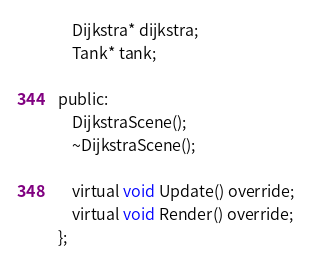<code> <loc_0><loc_0><loc_500><loc_500><_C_>	Dijkstra* dijkstra;
	Tank* tank;

public:
	DijkstraScene();
	~DijkstraScene();

	virtual void Update() override;
	virtual void Render() override;
};</code> 